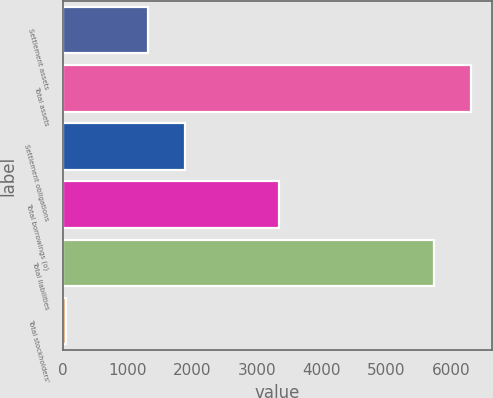<chart> <loc_0><loc_0><loc_500><loc_500><bar_chart><fcel>Settlement assets<fcel>Total assets<fcel>Settlement obligations<fcel>Total borrowings (o)<fcel>Total liabilities<fcel>Total stockholders'<nl><fcel>1319.2<fcel>6306.85<fcel>1892.55<fcel>3338<fcel>5733.5<fcel>50.7<nl></chart> 